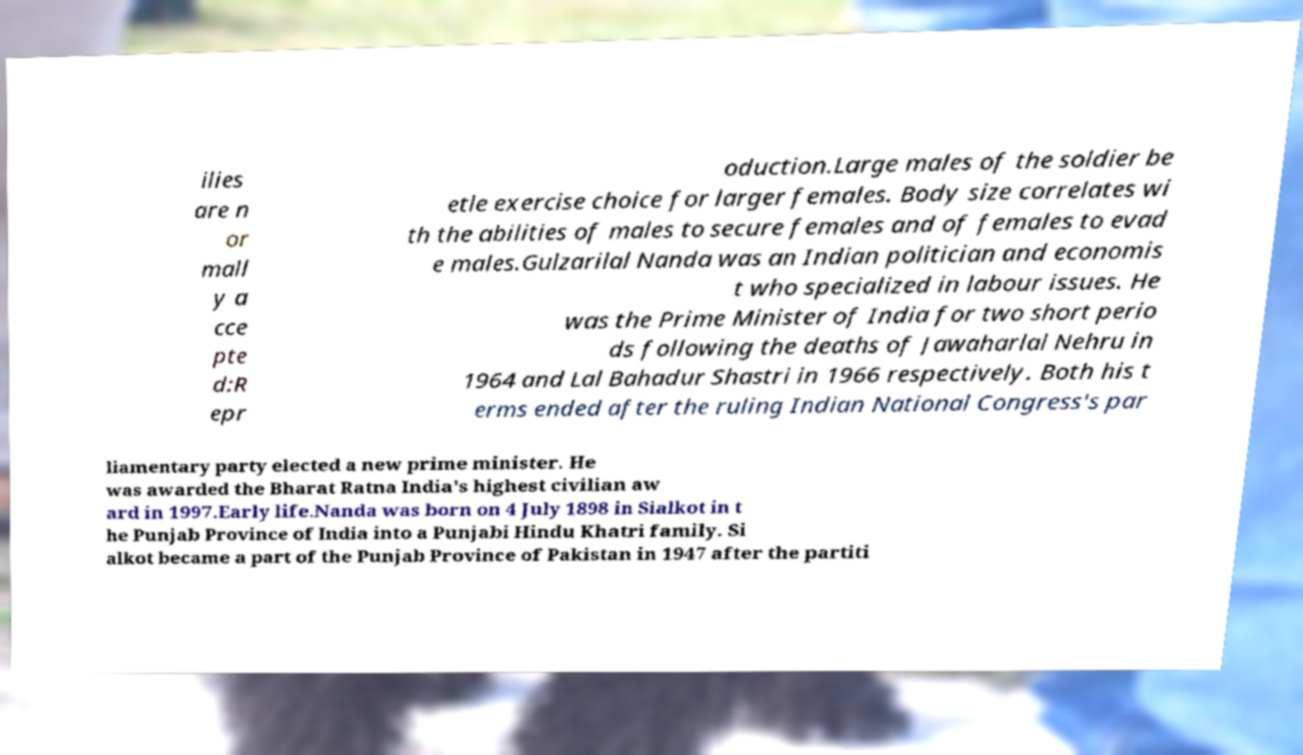Can you accurately transcribe the text from the provided image for me? ilies are n or mall y a cce pte d:R epr oduction.Large males of the soldier be etle exercise choice for larger females. Body size correlates wi th the abilities of males to secure females and of females to evad e males.Gulzarilal Nanda was an Indian politician and economis t who specialized in labour issues. He was the Prime Minister of India for two short perio ds following the deaths of Jawaharlal Nehru in 1964 and Lal Bahadur Shastri in 1966 respectively. Both his t erms ended after the ruling Indian National Congress's par liamentary party elected a new prime minister. He was awarded the Bharat Ratna India's highest civilian aw ard in 1997.Early life.Nanda was born on 4 July 1898 in Sialkot in t he Punjab Province of India into a Punjabi Hindu Khatri family. Si alkot became a part of the Punjab Province of Pakistan in 1947 after the partiti 